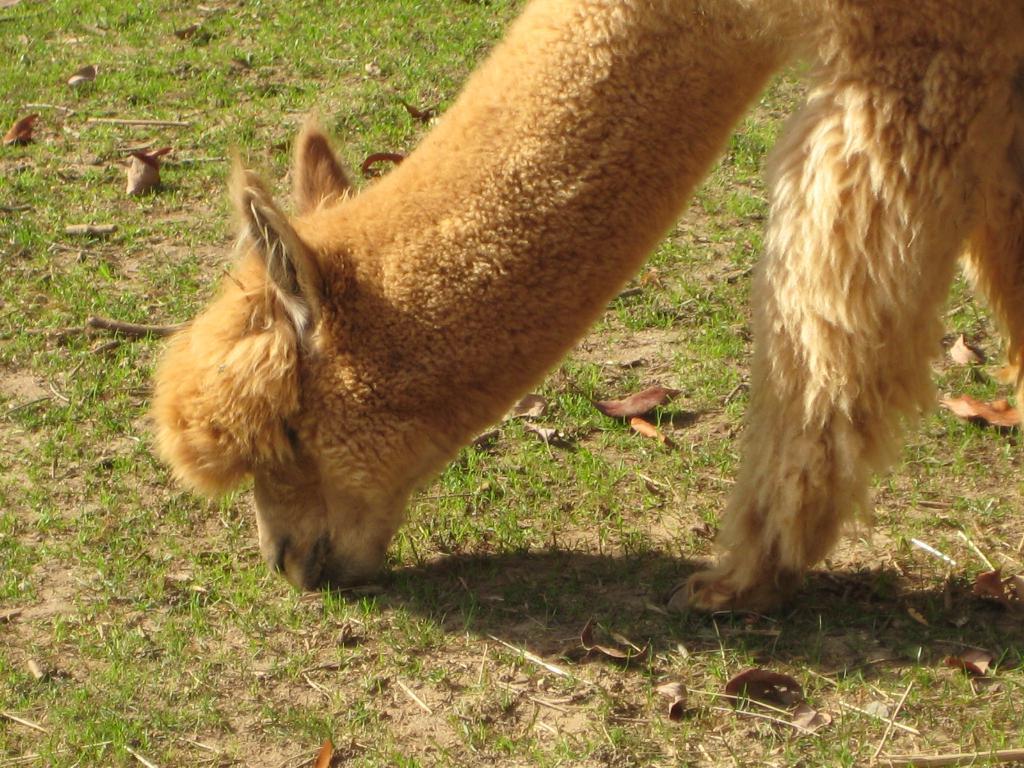Please provide a concise description of this image. In the image there is an animal grazing the grass. 